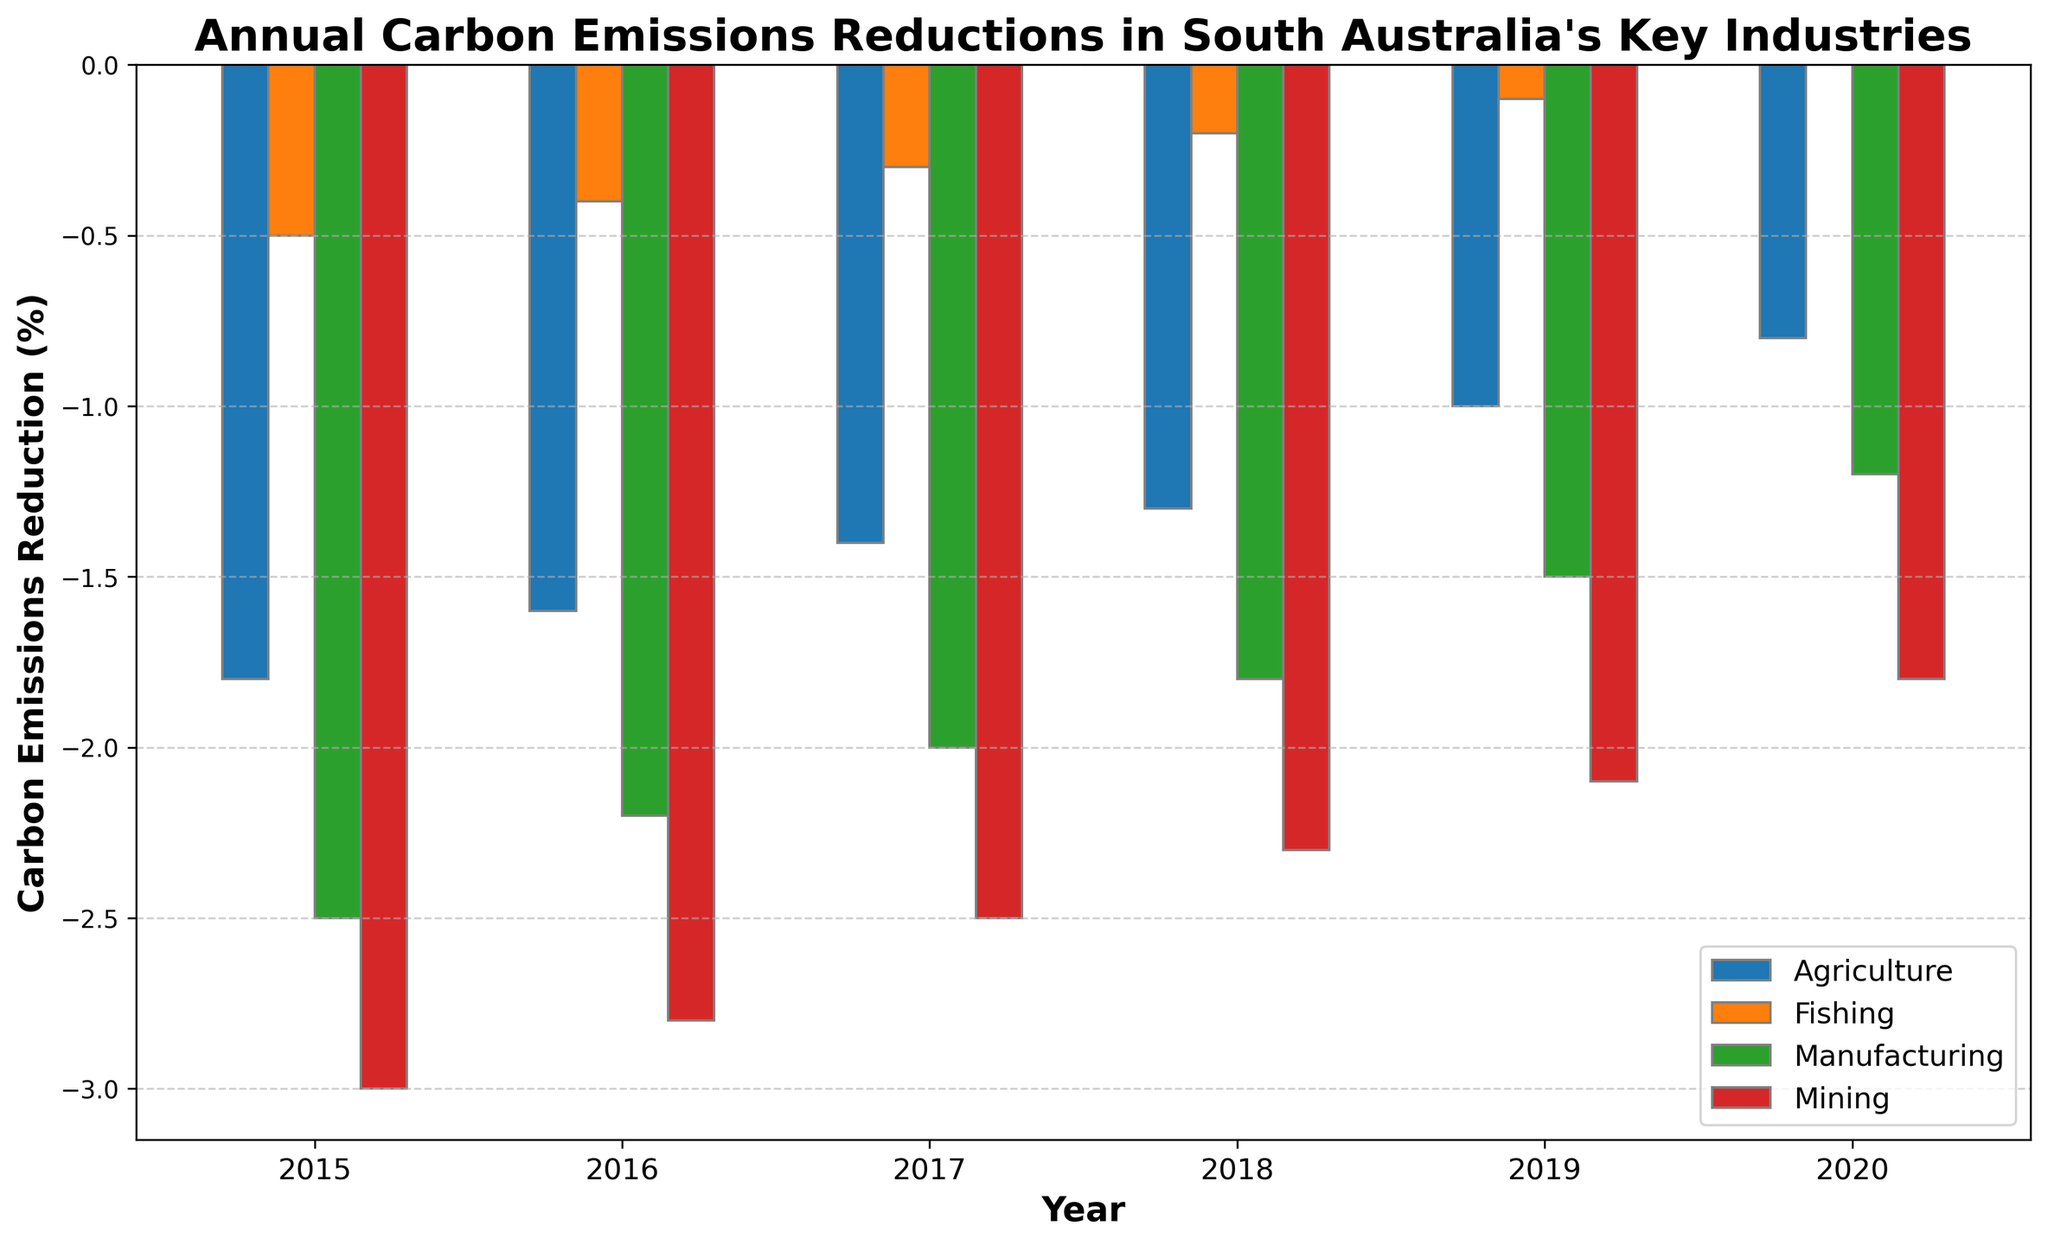Which industry had the highest carbon emissions reduction in 2015? Looking at the tallest negative bar in 2015, the Mining industry had the most significant reduction.
Answer: Mining Which year saw the lowest carbon emissions reduction in the Fishing industry? The smallest negative value in the Fishing's bars, reaching zero in 2020, indicates the lowest reduction (or no reduction).
Answer: 2020 Compare the carbon emissions reductions in Manufacturing between 2016 and 2018. Which year had a greater reduction? The height of the bar in 2016 is taller in the negative direction compared to 2018, showing a larger reduction in 2016.
Answer: 2016 Did the carbon emissions reduction in Agriculture improve or decline from 2017 to 2019? The height of the Agriculture bars shows less negative value in 2019 compared to 2017, indicating an improvement or lesser reduction.
Answer: Improve What is the average carbon emissions reduction in the Mining industry from 2015 to 2017? For Mining: (-3.0 + -2.8 + -2.5) / 3 = -2.77 (rounded to 2 decimal places). Calculate the sum of these values and then divide by 3.
Answer: -2.77 In which year did all four industries show the least reduction in carbon emissions on average? Calculate the average for each year: 2015=(-2.5+-1.8+-3.0+-0.5)/4, 2016=(-2.2+-1.6+-2.8+-0.4)/4, 2017=(-2.0+-1.4+-2.5+-0.3)/4, 2018=(-1.8+-1.3+-2.3+-0.2)/4, 2019=(-1.5+-1.0+-2.1+-0.1)/4, 2020=(-1.2+-0.8+-1.8+0)/4. 2020 has the smallest average reduction.
Answer: 2020 